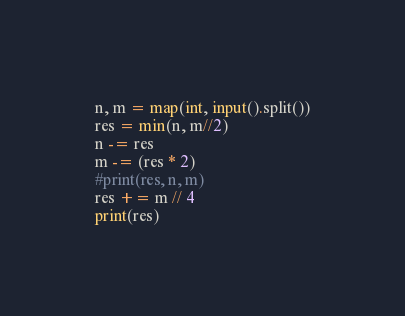<code> <loc_0><loc_0><loc_500><loc_500><_Python_>n, m = map(int, input().split())
res = min(n, m//2)
n -= res
m -= (res * 2)
#print(res, n, m)
res += m // 4
print(res)</code> 